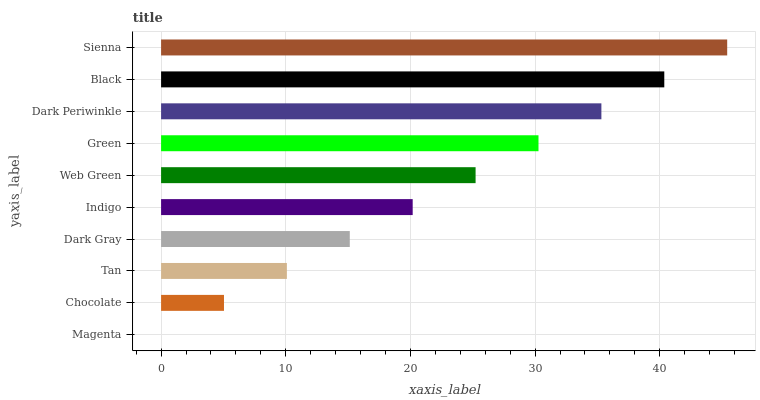Is Magenta the minimum?
Answer yes or no. Yes. Is Sienna the maximum?
Answer yes or no. Yes. Is Chocolate the minimum?
Answer yes or no. No. Is Chocolate the maximum?
Answer yes or no. No. Is Chocolate greater than Magenta?
Answer yes or no. Yes. Is Magenta less than Chocolate?
Answer yes or no. Yes. Is Magenta greater than Chocolate?
Answer yes or no. No. Is Chocolate less than Magenta?
Answer yes or no. No. Is Web Green the high median?
Answer yes or no. Yes. Is Indigo the low median?
Answer yes or no. Yes. Is Sienna the high median?
Answer yes or no. No. Is Black the low median?
Answer yes or no. No. 